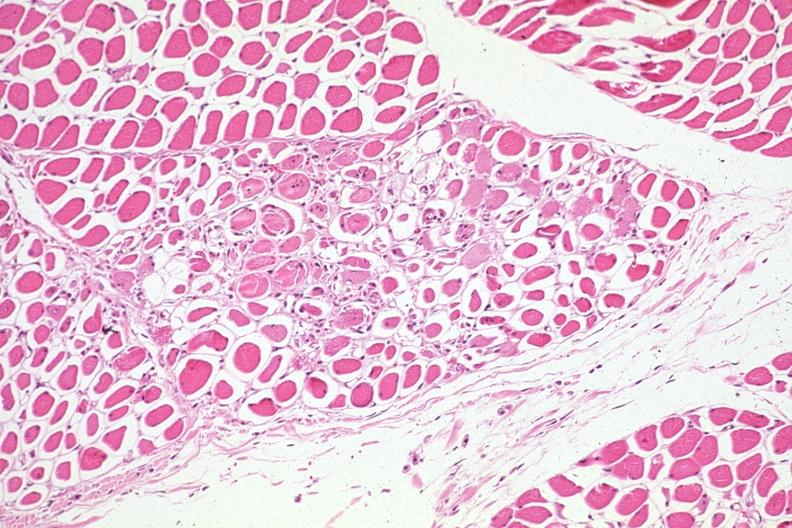s muscle present?
Answer the question using a single word or phrase. Yes 